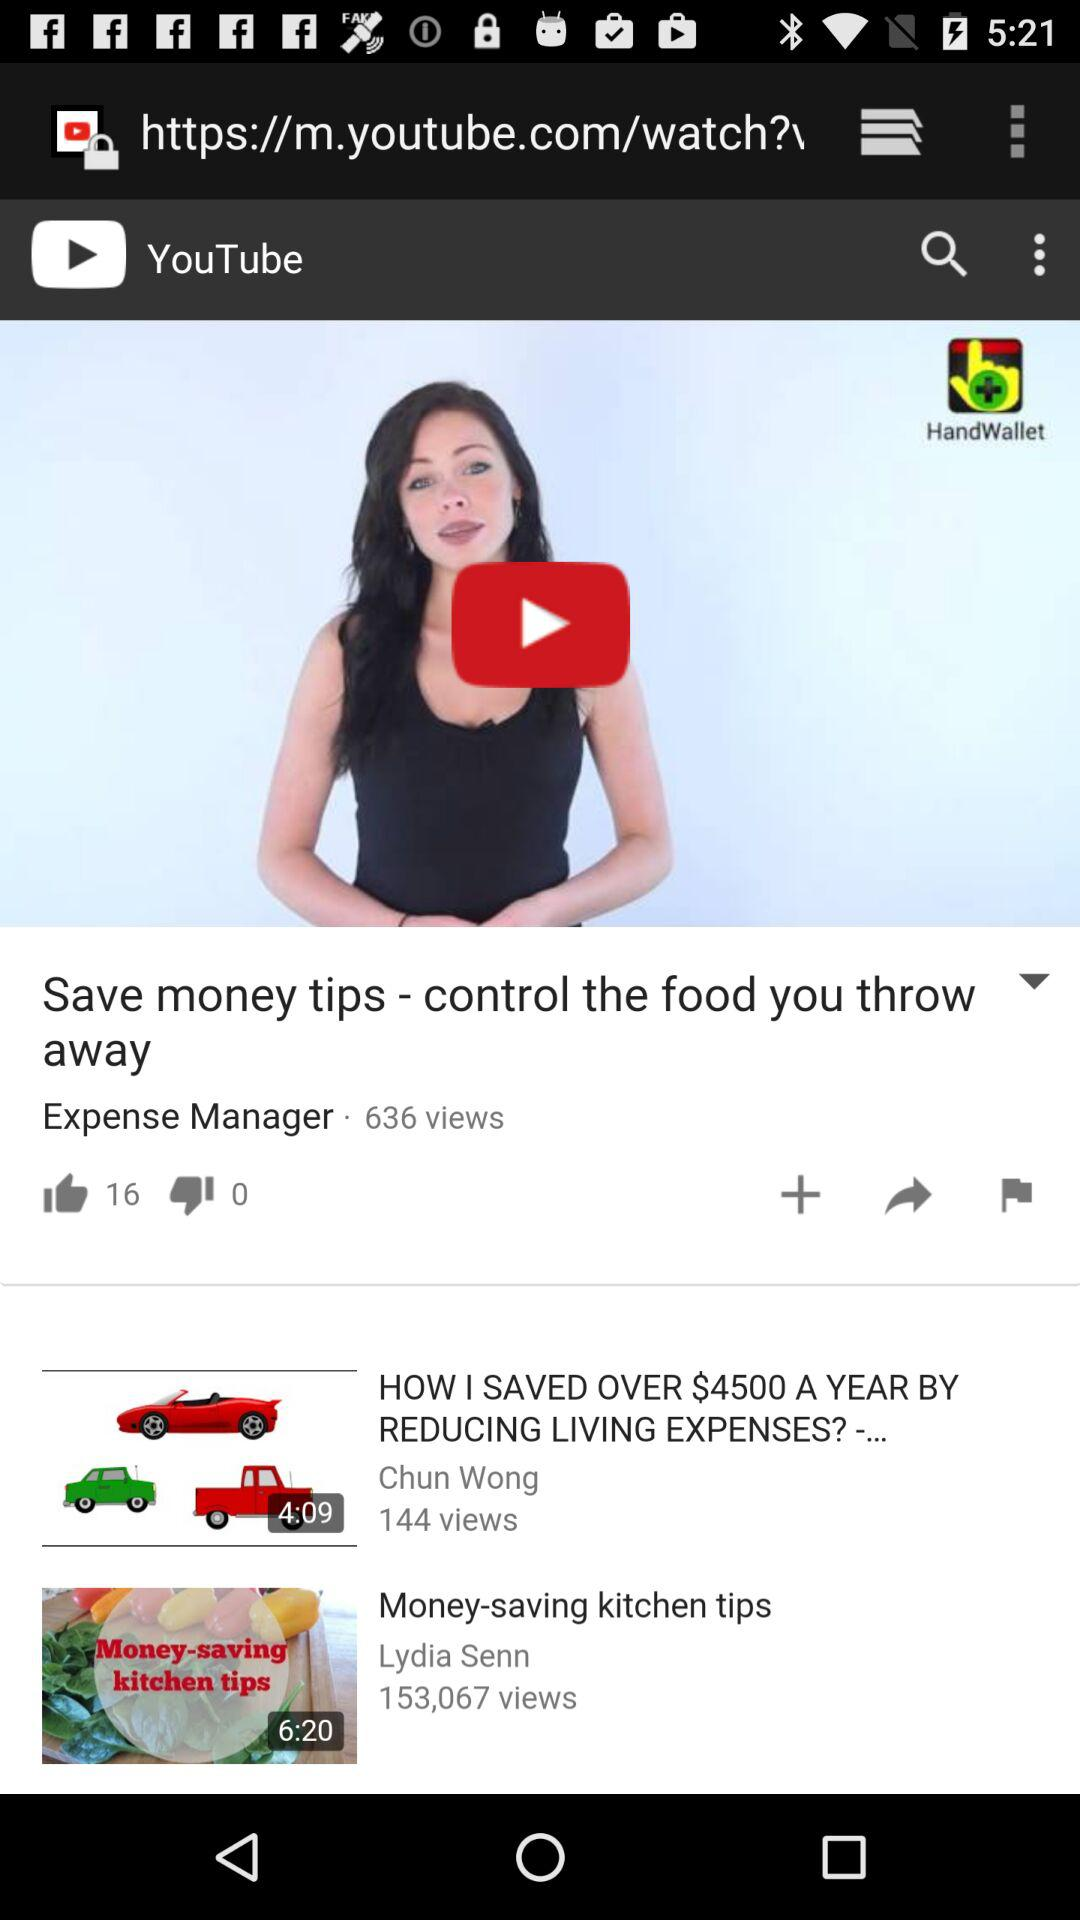How many views did the "Money-saving kitchen tips" video get? The number of views the video got was 153,067. 